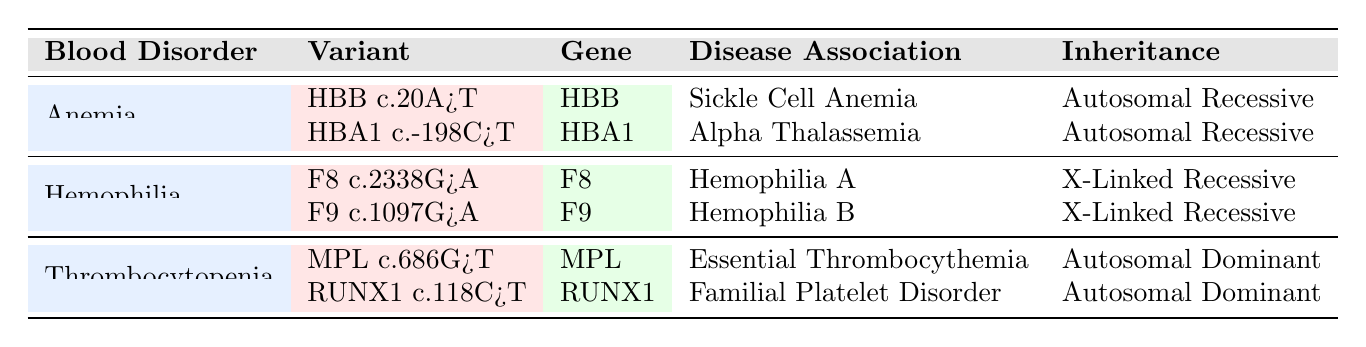What genetic variant is associated with Sickle Cell Anemia? The table lists the genetic variants related to different blood disorders. For Sickle Cell Anemia, the variant is "HBB c.20A>T".
Answer: HBB c.20A>T How many genetic variants are associated with Hemophilia? There are two variants listed under Hemophilia: "F8 c.2338G>A" and "F9 c.1097G>A".
Answer: 2 Is the inheritance pattern for Alpha Thalassemia Autosomal Dominant? According to the table, Alpha Thalassemia has an inheritance pattern of "Autosomal Recessive", therefore it is not Autosomal Dominant.
Answer: No What are the disease associations for the variants listed under Thrombocytopenia? Under Thrombocytopenia, the disease associations are "Essential Thrombocythemia" for "MPL c.686G>T" and "Familial Platelet Disorder" for "RUNX1 c.118C>T".
Answer: Essential Thrombocythemia and Familial Platelet Disorder Which genetic variant has the inheritance pattern of X-Linked Recessive? The table specifies that both variants under Hemophilia, "F8 c.2338G>A" and "F9 c.1097G>A", have the inheritance pattern of X-Linked Recessive.
Answer: F8 c.2338G>A and F9 c.1097G>A What is the total number of genetic variants listed for all blood disorders? Adding the variants from all categories: Anemia (2) + Hemophilia (2) + Thrombocytopenia (2) gives a total of 6 genetic variants.
Answer: 6 Which blood disorder has a genetic variant with Autosomal Dominant inheritance? The blood disorder Thrombocytopenia includes genetic variants "MPL c.686G>T" and "RUNX1 c.118C>T", both of which have Autosomal Dominant inheritance.
Answer: Thrombocytopenia Is "RUNX1 c.118C>T" associated with Hemophilia? The table indicates that "RUNX1 c.118C>T" is associated with "Familial Platelet Disorder" under Thrombocytopenia and not with Hemophilia.
Answer: No 